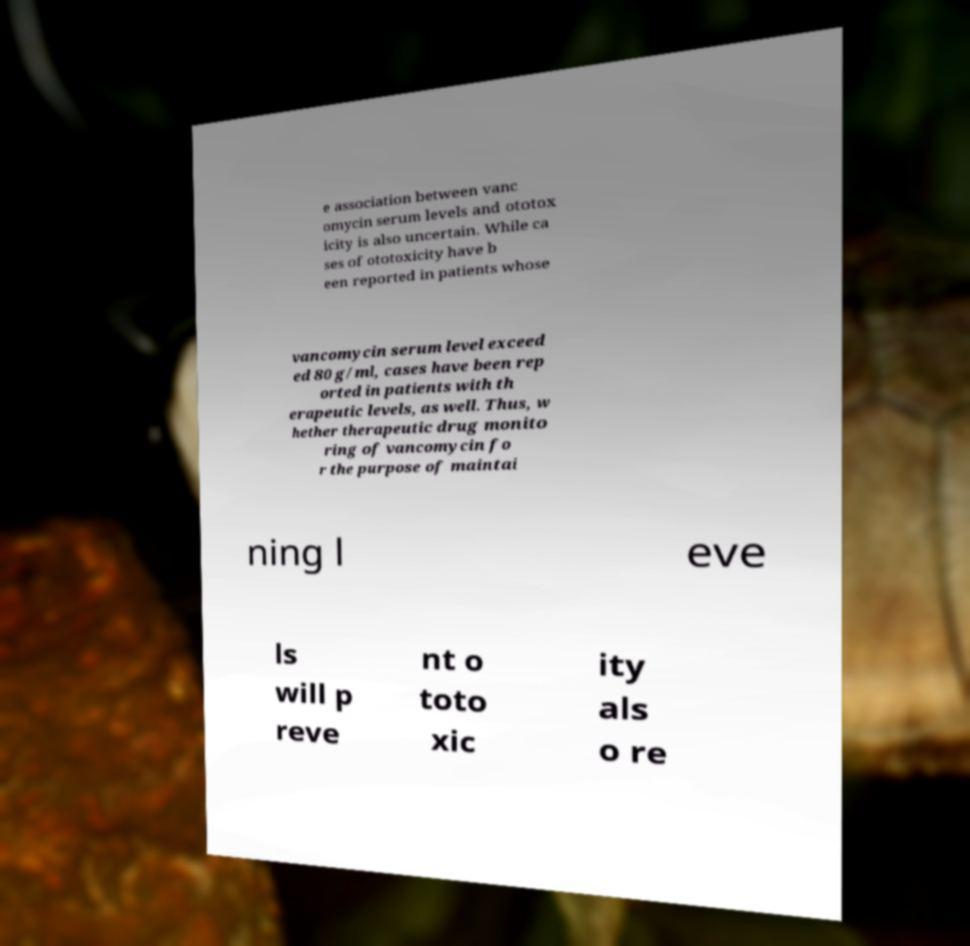For documentation purposes, I need the text within this image transcribed. Could you provide that? e association between vanc omycin serum levels and ototox icity is also uncertain. While ca ses of ototoxicity have b een reported in patients whose vancomycin serum level exceed ed 80 g/ml, cases have been rep orted in patients with th erapeutic levels, as well. Thus, w hether therapeutic drug monito ring of vancomycin fo r the purpose of maintai ning l eve ls will p reve nt o toto xic ity als o re 